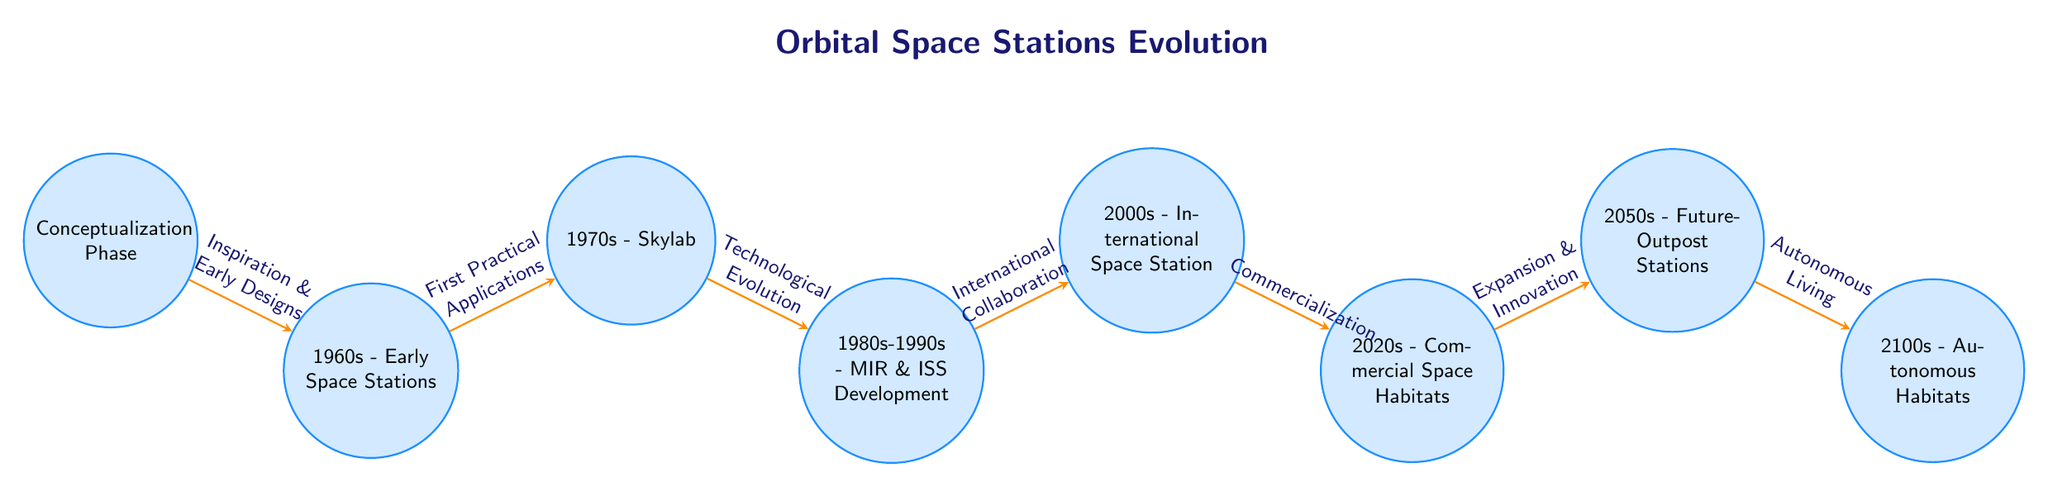What is the title of the diagram? The title is explicitly stated at the top of the diagram, labeled as "Orbital Space Stations Evolution."
Answer: Orbital Space Stations Evolution How many nodes are in the diagram? By counting each distinct phase labeled in the diagram, there are a total of eight nodes listed.
Answer: 8 What is the first phase in the evolution of orbital space stations? The first phase is titled "Conceptualization Phase," which is the initial node in the sequence.
Answer: Conceptualization Phase Which phase follows the "1970s - Skylab"? The diagram indicates that the next phase after "1970s - Skylab" is "1980s-1990s - MIR & ISS Development."
Answer: 1980s-1990s - MIR & ISS Development What concept is the connection between "2000s - International Space Station" and "2020s - Commercial Space Habitats"? The connection labeled between these two phases describes the transition as "Commercialization," indicating a shift towards commercial ventures in space habitats.
Answer: Commercialization What type of collaboration is highlighted from the "1980s-1990s - MIR & ISS Development" to the "2000s - International Space Station"? The diagram emphasizes "International Collaboration," which signifies the joint efforts among various countries to advance space station technologies.
Answer: International Collaboration How does the diagram depict the evolution towards living spaces in space? The diagram shows a progression labeled "Expansion & Innovation" leading into the future phase of "2050s - Future-Outpost Stations," indicating a continuous development toward more refined living setups in space.
Answer: Expansion & Innovation What change is indicated from "2050s - Future-Outpost Stations" to "2100s - Autonomous Habitats"? The transition is labeled as "Autonomous Living," suggesting a shift towards fully autonomous living environments in space by the 2100s.
Answer: Autonomous Living 